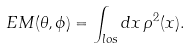Convert formula to latex. <formula><loc_0><loc_0><loc_500><loc_500>E M ( \theta , \phi ) = \int _ { l o s } d x \, \rho ^ { 2 } ( x ) .</formula> 